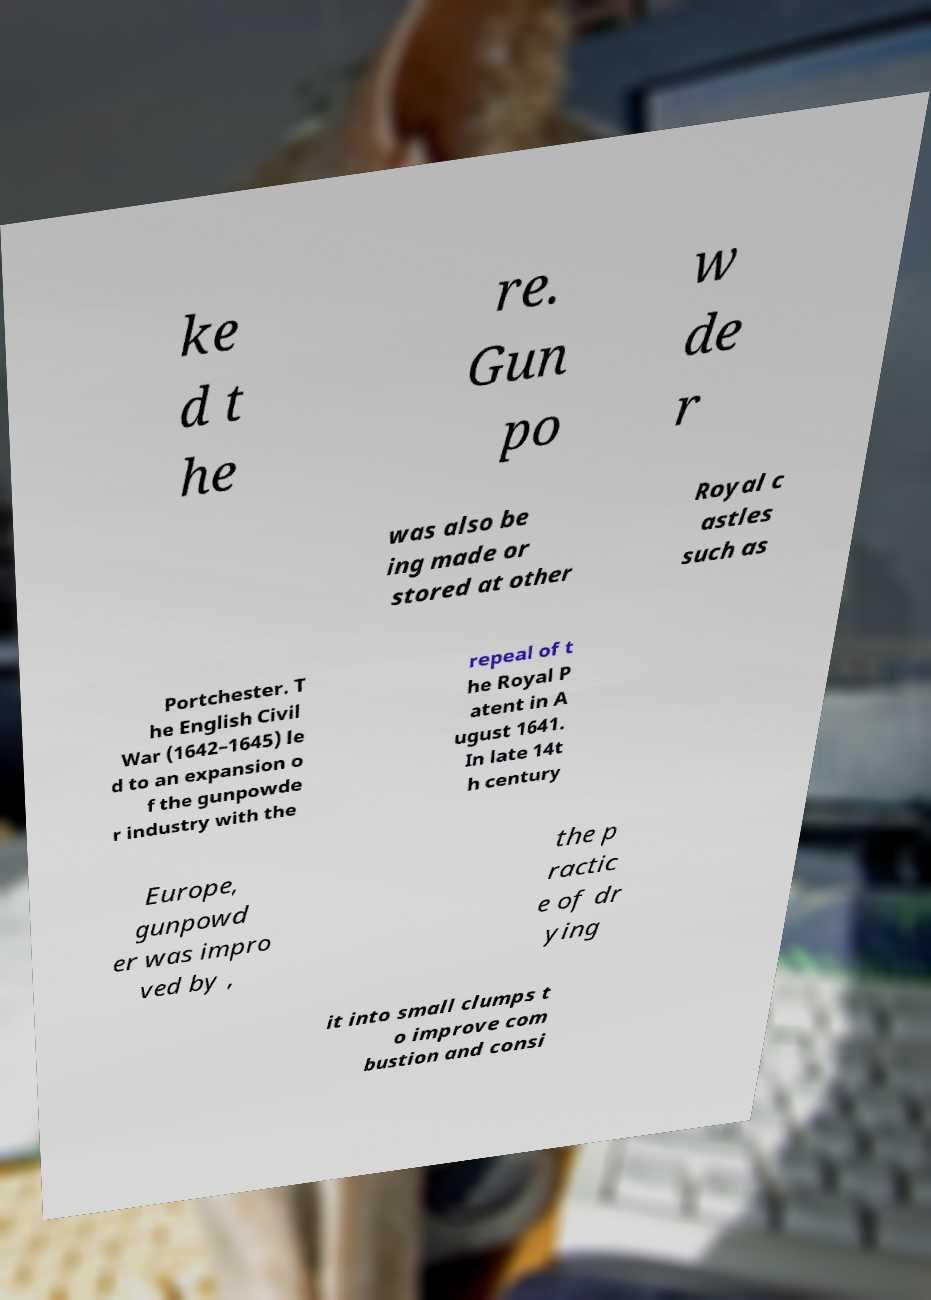There's text embedded in this image that I need extracted. Can you transcribe it verbatim? ke d t he re. Gun po w de r was also be ing made or stored at other Royal c astles such as Portchester. T he English Civil War (1642–1645) le d to an expansion o f the gunpowde r industry with the repeal of t he Royal P atent in A ugust 1641. In late 14t h century Europe, gunpowd er was impro ved by , the p ractic e of dr ying it into small clumps t o improve com bustion and consi 